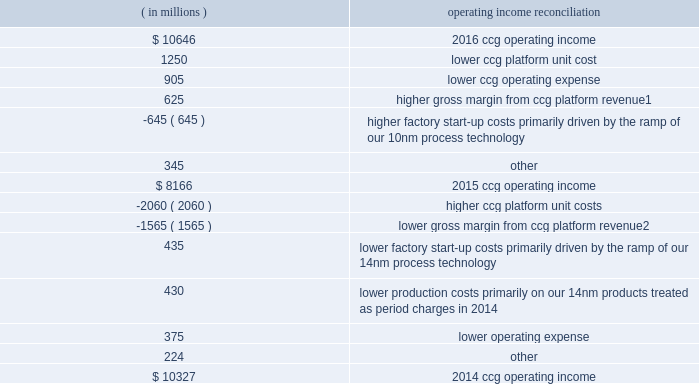Management 2019s discussion and analysis of financial condition and results of operations ( continued ) the following results drove changes in ccg operating income by approximately the amounts indicated: .
1 higher gross margin from higher ccg platform revenue was driven by higher average selling prices on notebook and desktop platforms , offset by lower desktop and notebook platform unit sales .
2 lower gross margin from lower ccg platform revenue was driven by lower desktop and notebook platform unit sales , partially offset by higher average selling prices on desktop , notebook , and tablet platforms .
Data center group segment product overview the dcg operating segment offers platforms designed to provide leading energy-efficient performance for all server , network , and storage applications .
In addition , dcg focuses on lowering the total cost of ownership on other specific workload- optimizations for the enterprise , cloud service providers , and communications service provider market segments .
In 2016 , we launched the following platforms with an array of functionalities and advancements : 2022 intel ae xeon ae processor e5 v4 family , the foundation for high performing clouds and delivers energy-efficient performance for server , network , and storage workloads .
2022 intel xeon processor e7 v4 family , targeted at platforms requiring four or more cpus ; this processor family delivers high performance and is optimized for real-time analytics and in-memory computing , along with industry-leading reliability , availability , and serviceability .
2022 intel ae xeon phi 2122 product family , formerly code-named knights landing , with up to 72 high-performance intel processor cores , integrated memory and fabric , and a common software programming model with intel xeon processors .
The intel xeon phi product family is designed for highly parallel compute and memory bandwidth-intensive workloads .
Intel xeon phi processors are positioned to increase the performance of supercomputers , enabling trillions of calculations per second , and to address emerging data analytics and artificial intelligence solutions .
In 2017 , we expect to release our next generation of intel xeon processors for compute , storage , and network ; a next-generation intel xeon phi processor optimized for deep learning ; and a suite of single-socket products , including next-generation intel xeon e3 processors , next-generation intel atom processors , and next-generation intel xeon-d processors for dense solutions. .
What is the growth rate in ccg operating income in 2016? 
Computations: ((10646 - 8166) / 8166)
Answer: 0.3037. 